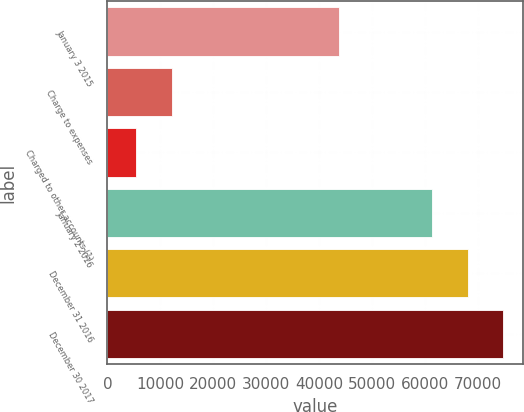Convert chart. <chart><loc_0><loc_0><loc_500><loc_500><bar_chart><fcel>January 3 2015<fcel>Charge to expenses<fcel>Charged to other accounts (1)<fcel>January 2 2016<fcel>December 31 2016<fcel>December 30 2017<nl><fcel>43757<fcel>12224<fcel>5377<fcel>61358<fcel>68080.5<fcel>74803<nl></chart> 